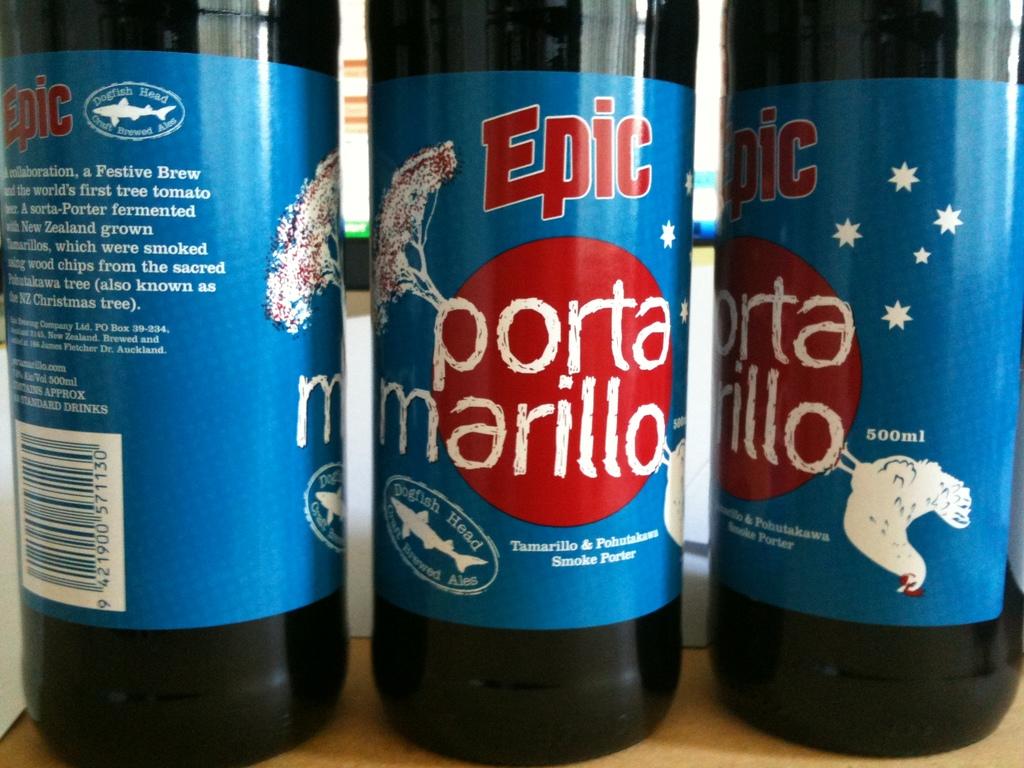Is this a porta marillo?
Offer a very short reply. Yes. 